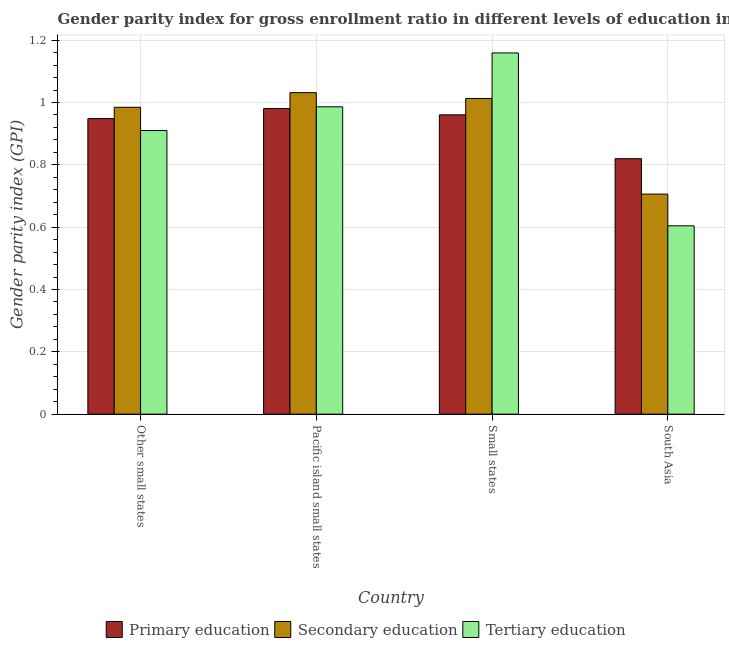Are the number of bars per tick equal to the number of legend labels?
Offer a terse response. Yes. Are the number of bars on each tick of the X-axis equal?
Offer a very short reply. Yes. How many bars are there on the 2nd tick from the left?
Your answer should be compact. 3. What is the label of the 3rd group of bars from the left?
Keep it short and to the point. Small states. In how many cases, is the number of bars for a given country not equal to the number of legend labels?
Your response must be concise. 0. What is the gender parity index in tertiary education in Small states?
Keep it short and to the point. 1.16. Across all countries, what is the maximum gender parity index in primary education?
Keep it short and to the point. 0.98. Across all countries, what is the minimum gender parity index in tertiary education?
Offer a terse response. 0.6. In which country was the gender parity index in primary education maximum?
Offer a terse response. Pacific island small states. What is the total gender parity index in tertiary education in the graph?
Offer a very short reply. 3.66. What is the difference between the gender parity index in primary education in Pacific island small states and that in Small states?
Provide a succinct answer. 0.02. What is the difference between the gender parity index in tertiary education in Small states and the gender parity index in primary education in South Asia?
Ensure brevity in your answer.  0.34. What is the average gender parity index in primary education per country?
Provide a short and direct response. 0.93. What is the difference between the gender parity index in tertiary education and gender parity index in primary education in Pacific island small states?
Make the answer very short. 0.01. In how many countries, is the gender parity index in secondary education greater than 0.8 ?
Ensure brevity in your answer.  3. What is the ratio of the gender parity index in primary education in Other small states to that in Pacific island small states?
Offer a very short reply. 0.97. What is the difference between the highest and the second highest gender parity index in primary education?
Provide a short and direct response. 0.02. What is the difference between the highest and the lowest gender parity index in primary education?
Your response must be concise. 0.16. In how many countries, is the gender parity index in tertiary education greater than the average gender parity index in tertiary education taken over all countries?
Offer a terse response. 2. What does the 3rd bar from the left in Other small states represents?
Offer a terse response. Tertiary education. What does the 3rd bar from the right in Other small states represents?
Your answer should be compact. Primary education. Is it the case that in every country, the sum of the gender parity index in primary education and gender parity index in secondary education is greater than the gender parity index in tertiary education?
Make the answer very short. Yes. Are all the bars in the graph horizontal?
Your answer should be very brief. No. How many countries are there in the graph?
Provide a short and direct response. 4. What is the difference between two consecutive major ticks on the Y-axis?
Give a very brief answer. 0.2. Does the graph contain grids?
Keep it short and to the point. Yes. Where does the legend appear in the graph?
Give a very brief answer. Bottom center. How are the legend labels stacked?
Make the answer very short. Horizontal. What is the title of the graph?
Your response must be concise. Gender parity index for gross enrollment ratio in different levels of education in 1998. What is the label or title of the X-axis?
Your answer should be very brief. Country. What is the label or title of the Y-axis?
Make the answer very short. Gender parity index (GPI). What is the Gender parity index (GPI) of Primary education in Other small states?
Provide a succinct answer. 0.95. What is the Gender parity index (GPI) in Secondary education in Other small states?
Offer a very short reply. 0.98. What is the Gender parity index (GPI) in Tertiary education in Other small states?
Offer a terse response. 0.91. What is the Gender parity index (GPI) in Primary education in Pacific island small states?
Provide a short and direct response. 0.98. What is the Gender parity index (GPI) in Secondary education in Pacific island small states?
Your response must be concise. 1.03. What is the Gender parity index (GPI) of Tertiary education in Pacific island small states?
Make the answer very short. 0.99. What is the Gender parity index (GPI) in Primary education in Small states?
Give a very brief answer. 0.96. What is the Gender parity index (GPI) in Secondary education in Small states?
Make the answer very short. 1.01. What is the Gender parity index (GPI) of Tertiary education in Small states?
Ensure brevity in your answer.  1.16. What is the Gender parity index (GPI) in Primary education in South Asia?
Keep it short and to the point. 0.82. What is the Gender parity index (GPI) in Secondary education in South Asia?
Give a very brief answer. 0.71. What is the Gender parity index (GPI) in Tertiary education in South Asia?
Your answer should be very brief. 0.6. Across all countries, what is the maximum Gender parity index (GPI) in Primary education?
Provide a short and direct response. 0.98. Across all countries, what is the maximum Gender parity index (GPI) in Secondary education?
Keep it short and to the point. 1.03. Across all countries, what is the maximum Gender parity index (GPI) in Tertiary education?
Offer a very short reply. 1.16. Across all countries, what is the minimum Gender parity index (GPI) of Primary education?
Offer a very short reply. 0.82. Across all countries, what is the minimum Gender parity index (GPI) of Secondary education?
Provide a succinct answer. 0.71. Across all countries, what is the minimum Gender parity index (GPI) of Tertiary education?
Offer a terse response. 0.6. What is the total Gender parity index (GPI) in Primary education in the graph?
Provide a short and direct response. 3.71. What is the total Gender parity index (GPI) of Secondary education in the graph?
Your answer should be compact. 3.74. What is the total Gender parity index (GPI) in Tertiary education in the graph?
Provide a succinct answer. 3.66. What is the difference between the Gender parity index (GPI) of Primary education in Other small states and that in Pacific island small states?
Your answer should be very brief. -0.03. What is the difference between the Gender parity index (GPI) in Secondary education in Other small states and that in Pacific island small states?
Keep it short and to the point. -0.05. What is the difference between the Gender parity index (GPI) of Tertiary education in Other small states and that in Pacific island small states?
Keep it short and to the point. -0.08. What is the difference between the Gender parity index (GPI) in Primary education in Other small states and that in Small states?
Keep it short and to the point. -0.01. What is the difference between the Gender parity index (GPI) of Secondary education in Other small states and that in Small states?
Provide a succinct answer. -0.03. What is the difference between the Gender parity index (GPI) in Tertiary education in Other small states and that in Small states?
Provide a short and direct response. -0.25. What is the difference between the Gender parity index (GPI) in Primary education in Other small states and that in South Asia?
Provide a short and direct response. 0.13. What is the difference between the Gender parity index (GPI) of Secondary education in Other small states and that in South Asia?
Ensure brevity in your answer.  0.28. What is the difference between the Gender parity index (GPI) of Tertiary education in Other small states and that in South Asia?
Offer a very short reply. 0.31. What is the difference between the Gender parity index (GPI) of Primary education in Pacific island small states and that in Small states?
Keep it short and to the point. 0.02. What is the difference between the Gender parity index (GPI) of Secondary education in Pacific island small states and that in Small states?
Provide a succinct answer. 0.02. What is the difference between the Gender parity index (GPI) in Tertiary education in Pacific island small states and that in Small states?
Your answer should be very brief. -0.17. What is the difference between the Gender parity index (GPI) in Primary education in Pacific island small states and that in South Asia?
Offer a terse response. 0.16. What is the difference between the Gender parity index (GPI) in Secondary education in Pacific island small states and that in South Asia?
Ensure brevity in your answer.  0.33. What is the difference between the Gender parity index (GPI) of Tertiary education in Pacific island small states and that in South Asia?
Provide a succinct answer. 0.38. What is the difference between the Gender parity index (GPI) of Primary education in Small states and that in South Asia?
Your answer should be compact. 0.14. What is the difference between the Gender parity index (GPI) of Secondary education in Small states and that in South Asia?
Your answer should be very brief. 0.31. What is the difference between the Gender parity index (GPI) of Tertiary education in Small states and that in South Asia?
Your response must be concise. 0.55. What is the difference between the Gender parity index (GPI) in Primary education in Other small states and the Gender parity index (GPI) in Secondary education in Pacific island small states?
Your response must be concise. -0.08. What is the difference between the Gender parity index (GPI) in Primary education in Other small states and the Gender parity index (GPI) in Tertiary education in Pacific island small states?
Give a very brief answer. -0.04. What is the difference between the Gender parity index (GPI) of Secondary education in Other small states and the Gender parity index (GPI) of Tertiary education in Pacific island small states?
Your response must be concise. -0. What is the difference between the Gender parity index (GPI) of Primary education in Other small states and the Gender parity index (GPI) of Secondary education in Small states?
Your answer should be very brief. -0.06. What is the difference between the Gender parity index (GPI) of Primary education in Other small states and the Gender parity index (GPI) of Tertiary education in Small states?
Your response must be concise. -0.21. What is the difference between the Gender parity index (GPI) of Secondary education in Other small states and the Gender parity index (GPI) of Tertiary education in Small states?
Offer a terse response. -0.17. What is the difference between the Gender parity index (GPI) in Primary education in Other small states and the Gender parity index (GPI) in Secondary education in South Asia?
Your answer should be compact. 0.24. What is the difference between the Gender parity index (GPI) in Primary education in Other small states and the Gender parity index (GPI) in Tertiary education in South Asia?
Give a very brief answer. 0.34. What is the difference between the Gender parity index (GPI) of Secondary education in Other small states and the Gender parity index (GPI) of Tertiary education in South Asia?
Keep it short and to the point. 0.38. What is the difference between the Gender parity index (GPI) of Primary education in Pacific island small states and the Gender parity index (GPI) of Secondary education in Small states?
Provide a succinct answer. -0.03. What is the difference between the Gender parity index (GPI) of Primary education in Pacific island small states and the Gender parity index (GPI) of Tertiary education in Small states?
Keep it short and to the point. -0.18. What is the difference between the Gender parity index (GPI) in Secondary education in Pacific island small states and the Gender parity index (GPI) in Tertiary education in Small states?
Offer a very short reply. -0.13. What is the difference between the Gender parity index (GPI) in Primary education in Pacific island small states and the Gender parity index (GPI) in Secondary education in South Asia?
Give a very brief answer. 0.27. What is the difference between the Gender parity index (GPI) of Primary education in Pacific island small states and the Gender parity index (GPI) of Tertiary education in South Asia?
Ensure brevity in your answer.  0.38. What is the difference between the Gender parity index (GPI) of Secondary education in Pacific island small states and the Gender parity index (GPI) of Tertiary education in South Asia?
Your answer should be very brief. 0.43. What is the difference between the Gender parity index (GPI) in Primary education in Small states and the Gender parity index (GPI) in Secondary education in South Asia?
Make the answer very short. 0.25. What is the difference between the Gender parity index (GPI) of Primary education in Small states and the Gender parity index (GPI) of Tertiary education in South Asia?
Give a very brief answer. 0.36. What is the difference between the Gender parity index (GPI) in Secondary education in Small states and the Gender parity index (GPI) in Tertiary education in South Asia?
Provide a short and direct response. 0.41. What is the average Gender parity index (GPI) in Primary education per country?
Give a very brief answer. 0.93. What is the average Gender parity index (GPI) of Secondary education per country?
Your response must be concise. 0.93. What is the average Gender parity index (GPI) in Tertiary education per country?
Provide a succinct answer. 0.91. What is the difference between the Gender parity index (GPI) in Primary education and Gender parity index (GPI) in Secondary education in Other small states?
Your answer should be compact. -0.04. What is the difference between the Gender parity index (GPI) of Primary education and Gender parity index (GPI) of Tertiary education in Other small states?
Ensure brevity in your answer.  0.04. What is the difference between the Gender parity index (GPI) of Secondary education and Gender parity index (GPI) of Tertiary education in Other small states?
Provide a short and direct response. 0.07. What is the difference between the Gender parity index (GPI) of Primary education and Gender parity index (GPI) of Secondary education in Pacific island small states?
Make the answer very short. -0.05. What is the difference between the Gender parity index (GPI) in Primary education and Gender parity index (GPI) in Tertiary education in Pacific island small states?
Offer a very short reply. -0.01. What is the difference between the Gender parity index (GPI) in Secondary education and Gender parity index (GPI) in Tertiary education in Pacific island small states?
Your response must be concise. 0.05. What is the difference between the Gender parity index (GPI) in Primary education and Gender parity index (GPI) in Secondary education in Small states?
Provide a succinct answer. -0.05. What is the difference between the Gender parity index (GPI) in Primary education and Gender parity index (GPI) in Tertiary education in Small states?
Give a very brief answer. -0.2. What is the difference between the Gender parity index (GPI) in Secondary education and Gender parity index (GPI) in Tertiary education in Small states?
Provide a succinct answer. -0.15. What is the difference between the Gender parity index (GPI) in Primary education and Gender parity index (GPI) in Secondary education in South Asia?
Provide a succinct answer. 0.11. What is the difference between the Gender parity index (GPI) of Primary education and Gender parity index (GPI) of Tertiary education in South Asia?
Keep it short and to the point. 0.22. What is the difference between the Gender parity index (GPI) in Secondary education and Gender parity index (GPI) in Tertiary education in South Asia?
Give a very brief answer. 0.1. What is the ratio of the Gender parity index (GPI) of Primary education in Other small states to that in Pacific island small states?
Your answer should be compact. 0.97. What is the ratio of the Gender parity index (GPI) in Secondary education in Other small states to that in Pacific island small states?
Provide a succinct answer. 0.95. What is the ratio of the Gender parity index (GPI) in Tertiary education in Other small states to that in Pacific island small states?
Provide a short and direct response. 0.92. What is the ratio of the Gender parity index (GPI) of Primary education in Other small states to that in Small states?
Give a very brief answer. 0.99. What is the ratio of the Gender parity index (GPI) of Secondary education in Other small states to that in Small states?
Offer a terse response. 0.97. What is the ratio of the Gender parity index (GPI) in Tertiary education in Other small states to that in Small states?
Offer a very short reply. 0.79. What is the ratio of the Gender parity index (GPI) of Primary education in Other small states to that in South Asia?
Your response must be concise. 1.16. What is the ratio of the Gender parity index (GPI) in Secondary education in Other small states to that in South Asia?
Give a very brief answer. 1.39. What is the ratio of the Gender parity index (GPI) in Tertiary education in Other small states to that in South Asia?
Your answer should be very brief. 1.51. What is the ratio of the Gender parity index (GPI) in Primary education in Pacific island small states to that in Small states?
Ensure brevity in your answer.  1.02. What is the ratio of the Gender parity index (GPI) of Secondary education in Pacific island small states to that in Small states?
Provide a short and direct response. 1.02. What is the ratio of the Gender parity index (GPI) in Tertiary education in Pacific island small states to that in Small states?
Make the answer very short. 0.85. What is the ratio of the Gender parity index (GPI) of Primary education in Pacific island small states to that in South Asia?
Your answer should be compact. 1.2. What is the ratio of the Gender parity index (GPI) of Secondary education in Pacific island small states to that in South Asia?
Make the answer very short. 1.46. What is the ratio of the Gender parity index (GPI) of Tertiary education in Pacific island small states to that in South Asia?
Make the answer very short. 1.63. What is the ratio of the Gender parity index (GPI) in Primary education in Small states to that in South Asia?
Your answer should be compact. 1.17. What is the ratio of the Gender parity index (GPI) of Secondary education in Small states to that in South Asia?
Offer a terse response. 1.43. What is the ratio of the Gender parity index (GPI) in Tertiary education in Small states to that in South Asia?
Offer a very short reply. 1.92. What is the difference between the highest and the second highest Gender parity index (GPI) of Primary education?
Give a very brief answer. 0.02. What is the difference between the highest and the second highest Gender parity index (GPI) of Secondary education?
Keep it short and to the point. 0.02. What is the difference between the highest and the second highest Gender parity index (GPI) in Tertiary education?
Your answer should be compact. 0.17. What is the difference between the highest and the lowest Gender parity index (GPI) in Primary education?
Your response must be concise. 0.16. What is the difference between the highest and the lowest Gender parity index (GPI) of Secondary education?
Provide a succinct answer. 0.33. What is the difference between the highest and the lowest Gender parity index (GPI) of Tertiary education?
Offer a terse response. 0.55. 